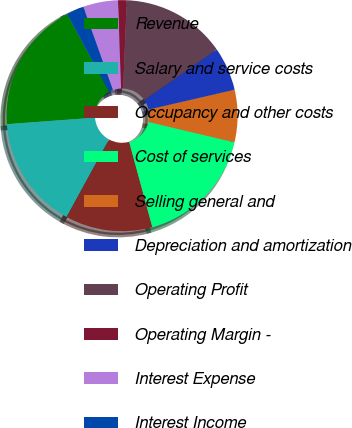Convert chart to OTSL. <chart><loc_0><loc_0><loc_500><loc_500><pie_chart><fcel>Revenue<fcel>Salary and service costs<fcel>Occupancy and other costs<fcel>Cost of services<fcel>Selling general and<fcel>Depreciation and amortization<fcel>Operating Profit<fcel>Operating Margin -<fcel>Interest Expense<fcel>Interest Income<nl><fcel>18.29%<fcel>15.85%<fcel>12.19%<fcel>17.07%<fcel>7.32%<fcel>6.1%<fcel>14.63%<fcel>1.22%<fcel>4.88%<fcel>2.44%<nl></chart> 